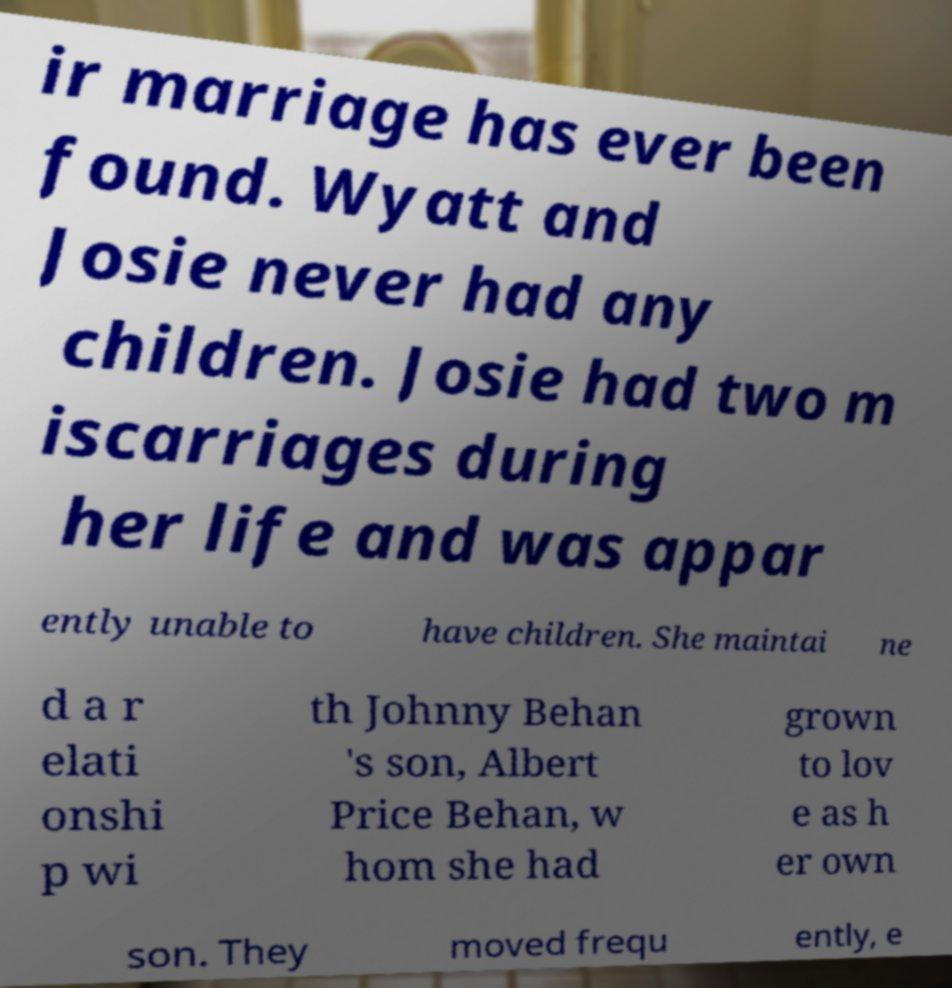Please read and relay the text visible in this image. What does it say? ir marriage has ever been found. Wyatt and Josie never had any children. Josie had two m iscarriages during her life and was appar ently unable to have children. She maintai ne d a r elati onshi p wi th Johnny Behan 's son, Albert Price Behan, w hom she had grown to lov e as h er own son. They moved frequ ently, e 